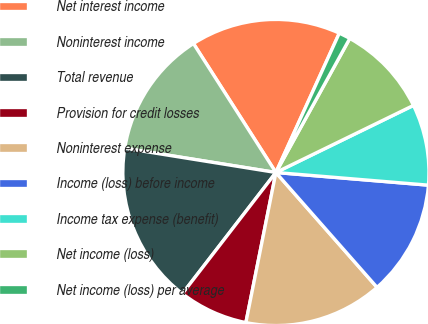<chart> <loc_0><loc_0><loc_500><loc_500><pie_chart><fcel>Net interest income<fcel>Noninterest income<fcel>Total revenue<fcel>Provision for credit losses<fcel>Noninterest expense<fcel>Income (loss) before income<fcel>Income tax expense (benefit)<fcel>Net income (loss)<fcel>Net income (loss) per average<nl><fcel>15.85%<fcel>13.41%<fcel>17.07%<fcel>7.32%<fcel>14.63%<fcel>12.19%<fcel>8.54%<fcel>9.76%<fcel>1.22%<nl></chart> 